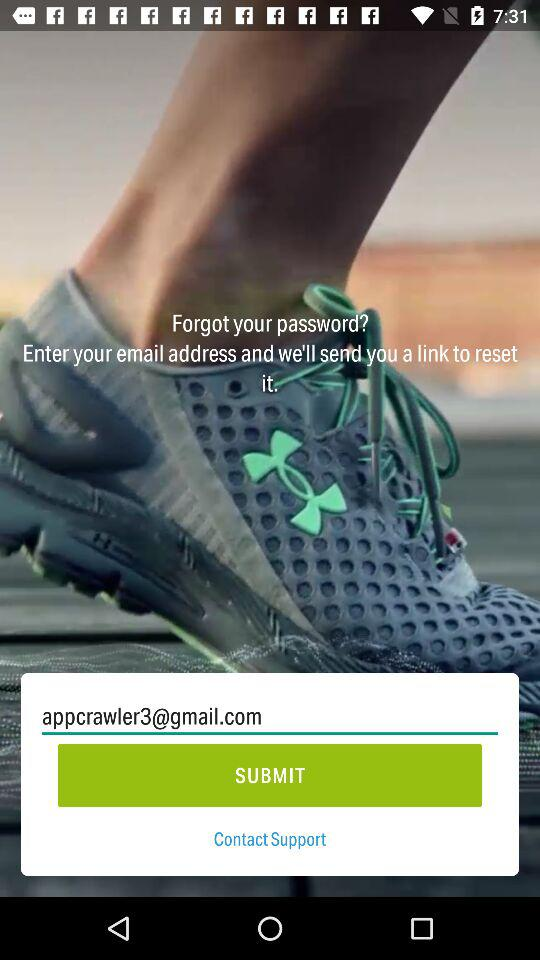What is the email address? The email address is appcrawler3@gmail.com. 